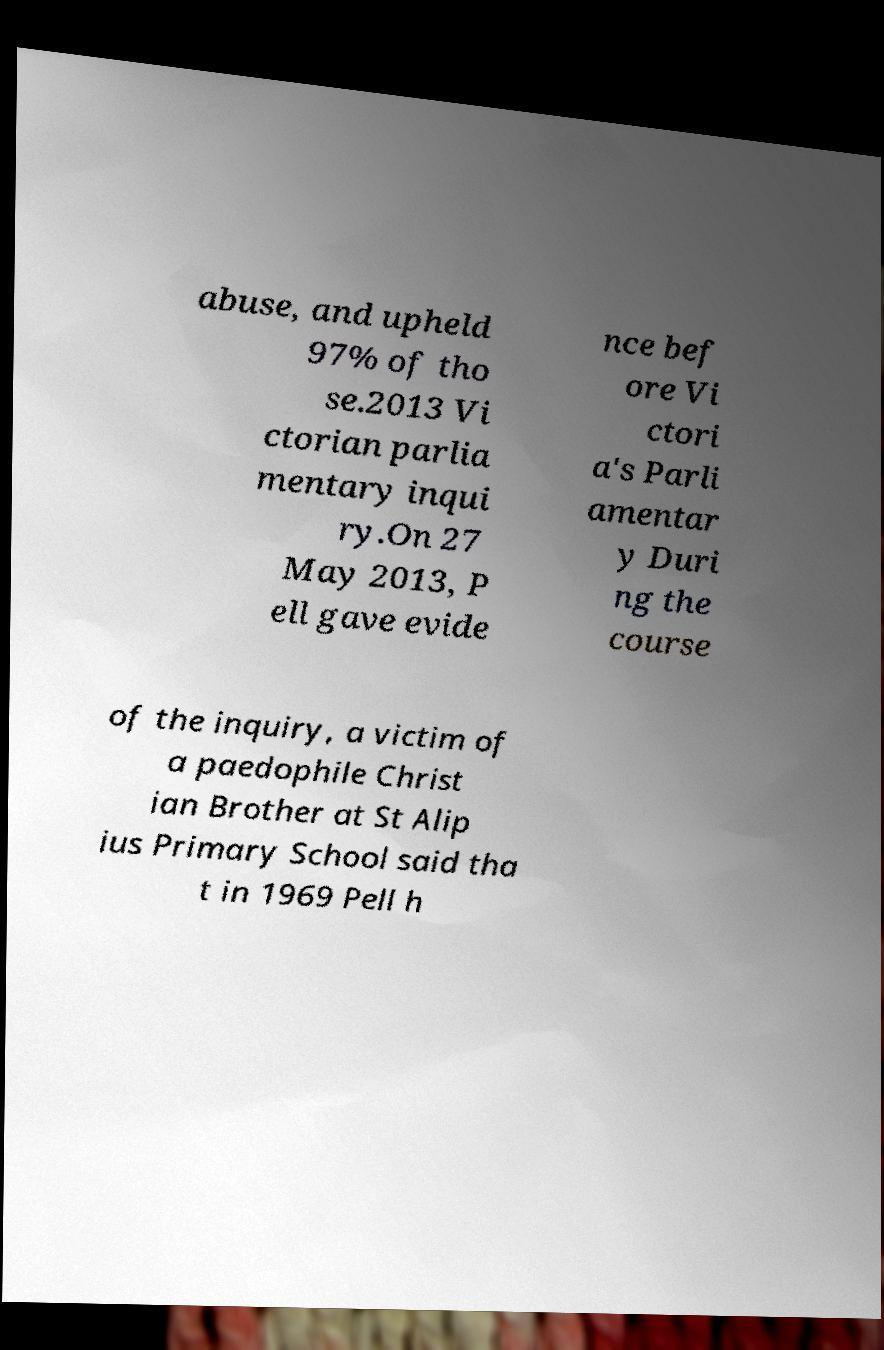Could you extract and type out the text from this image? abuse, and upheld 97% of tho se.2013 Vi ctorian parlia mentary inqui ry.On 27 May 2013, P ell gave evide nce bef ore Vi ctori a's Parli amentar y Duri ng the course of the inquiry, a victim of a paedophile Christ ian Brother at St Alip ius Primary School said tha t in 1969 Pell h 